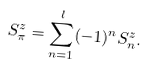Convert formula to latex. <formula><loc_0><loc_0><loc_500><loc_500>S ^ { z } _ { \pi } = \sum _ { n = 1 } ^ { l } ( - 1 ) ^ { n } S ^ { z } _ { n } .</formula> 